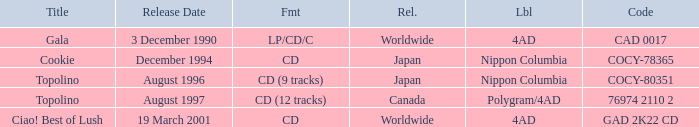What format was released in August 1996? CD (9 tracks). 